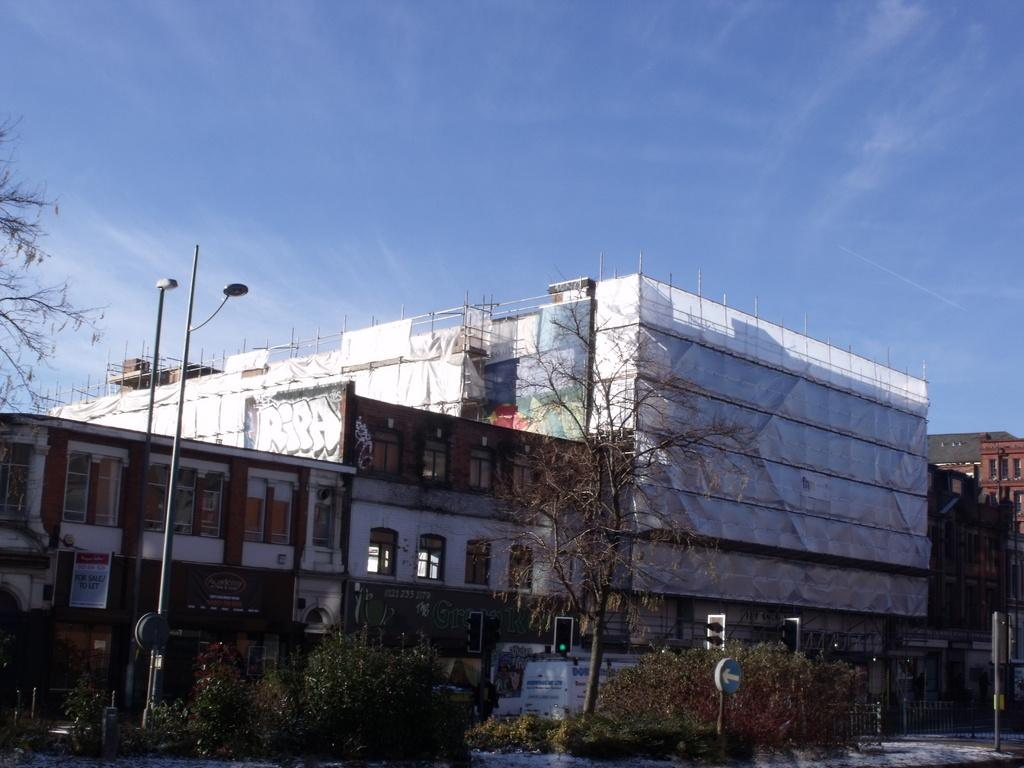What types of objects can be seen in the image? There are plants, light poles, traffic signal poles, caution boards, buildings, and trees visible in the image. What can be seen in the sky in the background of the image? The sky is blue in the background of the image, and there are clouds present. What type of music is being played by the frogs in the image? There are no frogs present in the image, and therefore no music can be heard. Can you tell me how many lawyers are visible in the image? There are no lawyers present in the image. 